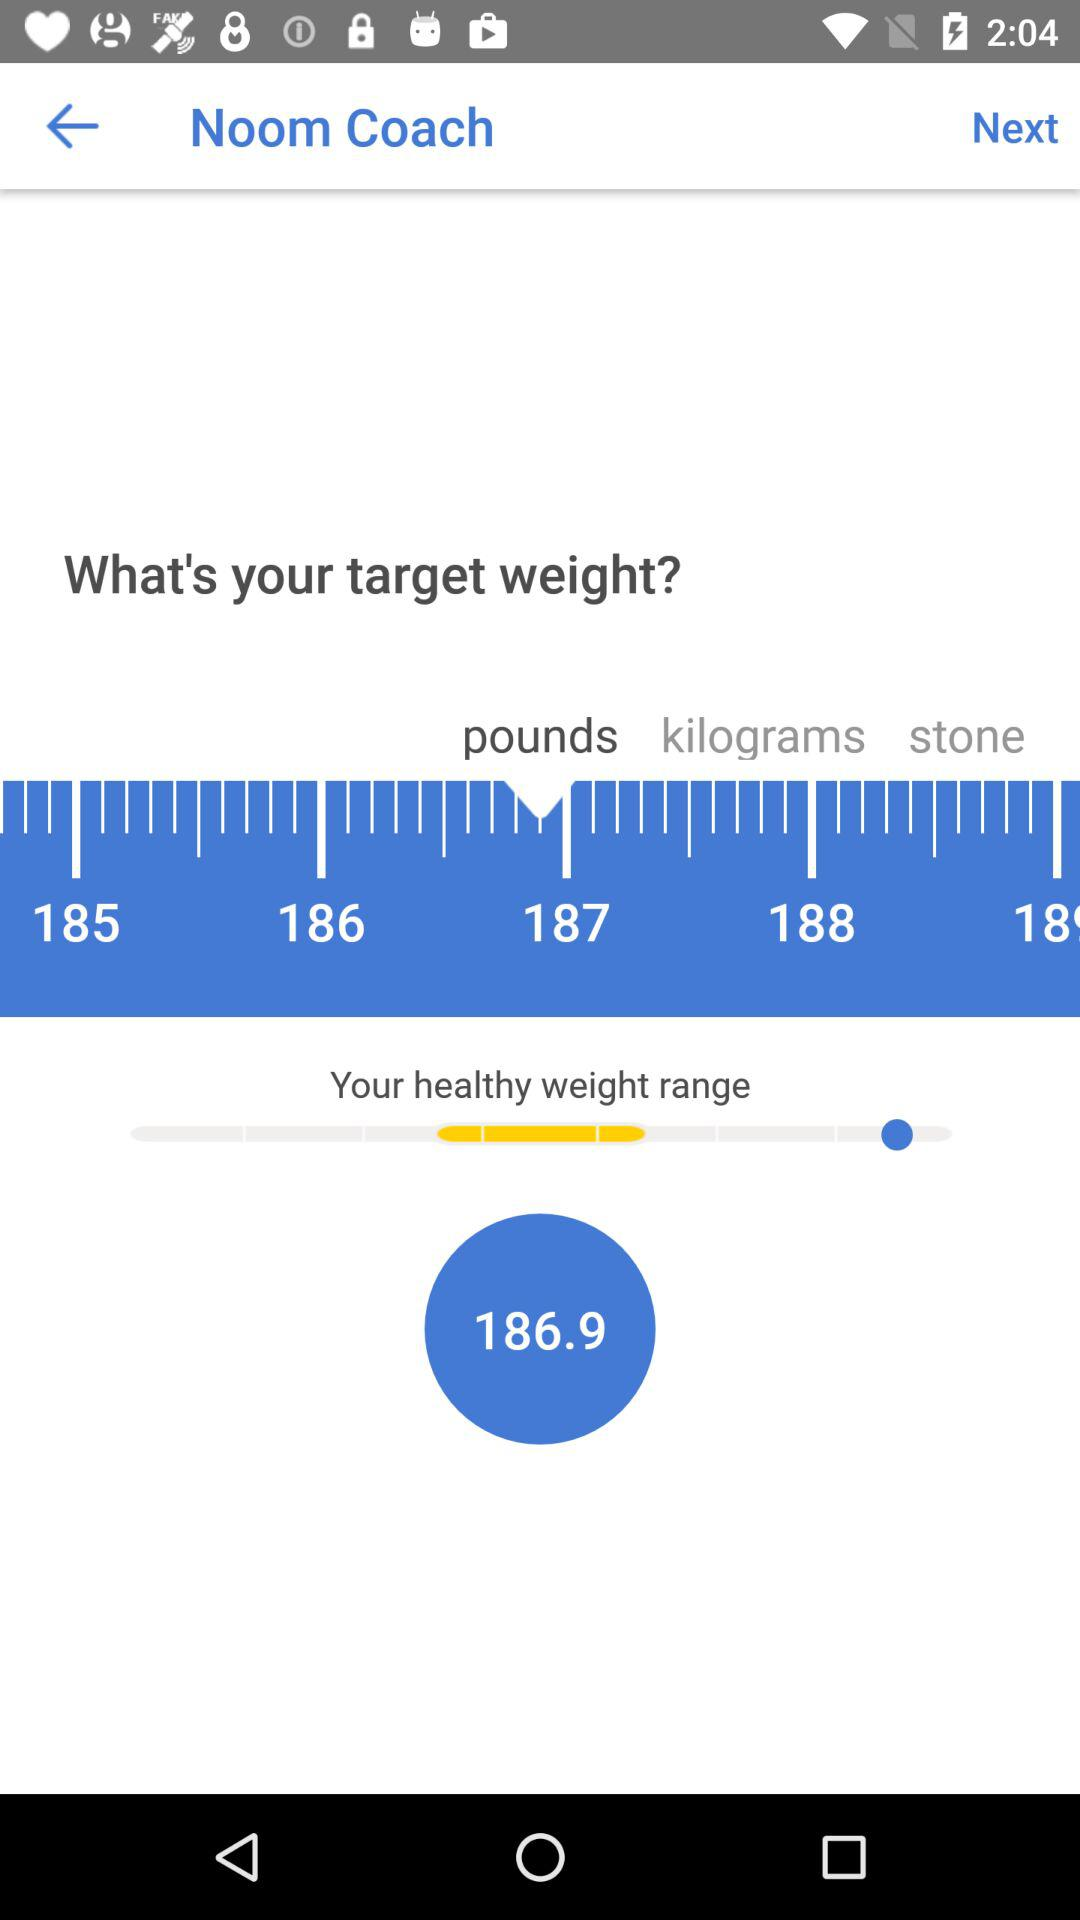How many weight units are available?
Answer the question using a single word or phrase. 3 